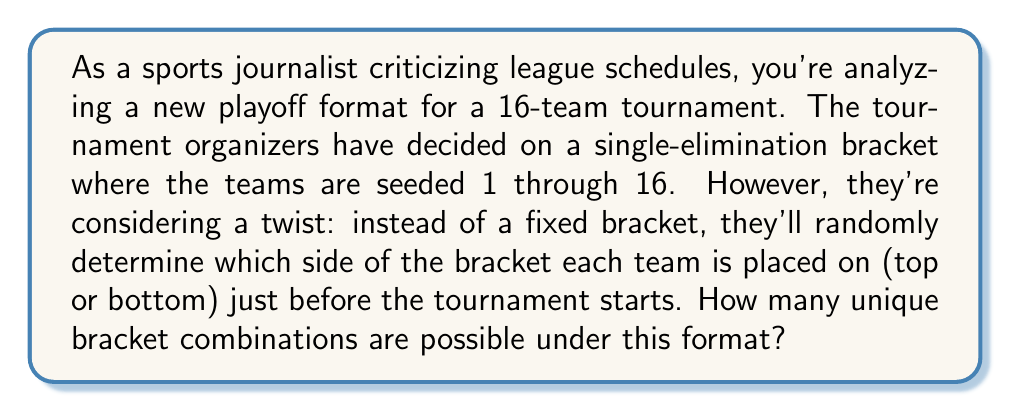Show me your answer to this math problem. To solve this problem, let's break it down step-by-step:

1) In a 16-team single-elimination tournament, there are 15 games in total (8 in the first round, 4 in the second, 2 in the semifinals, and 1 in the final).

2) For each game, we need to determine which team goes on which side of the bracket (top or bottom). This is equivalent to making a binary choice for each team.

3) Since there are 16 teams, we need to make 16 independent binary choices (top or bottom of the bracket for each team).

4) Each of these choices can be made in 2 ways (top or bottom).

5) According to the multiplication principle, when we have a series of independent choices, we multiply the number of ways each choice can be made.

6) Therefore, the total number of unique bracket combinations is:

   $$2 \times 2 \times 2 \times ... \times 2$$ (16 times)

   This can be written as:

   $$2^{16}$$

7) Calculating this:

   $$2^{16} = 65,536$$

Thus, there are 65,536 unique ways to arrange the teams in the bracket under this format.
Answer: $2^{16} = 65,536$ unique bracket combinations 